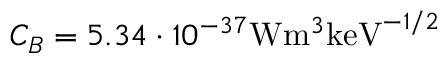<formula> <loc_0><loc_0><loc_500><loc_500>C _ { B } = 5 . 3 4 \cdot 1 0 ^ { - 3 7 } W m ^ { 3 } k e V ^ { - 1 / 2 }</formula> 